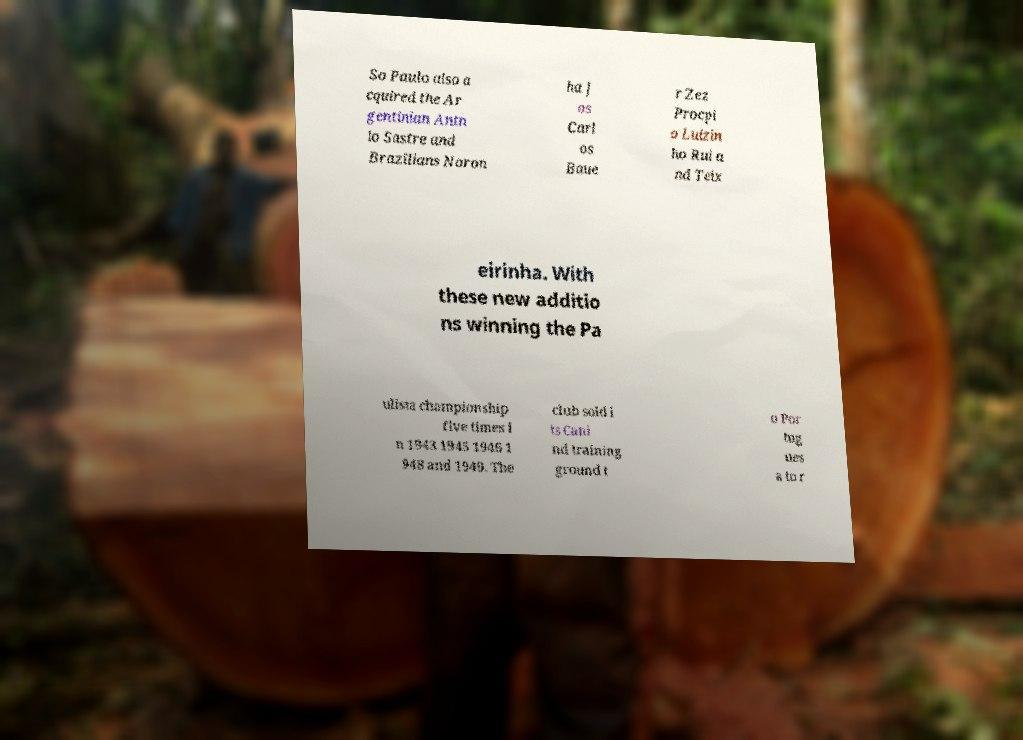Can you accurately transcribe the text from the provided image for me? So Paulo also a cquired the Ar gentinian Antn io Sastre and Brazilians Noron ha J os Carl os Baue r Zez Procpi o Luizin ho Rui a nd Teix eirinha. With these new additio ns winning the Pa ulista championship five times i n 1943 1945 1946 1 948 and 1949. The club sold i ts Cani nd training ground t o Por tug ues a to r 